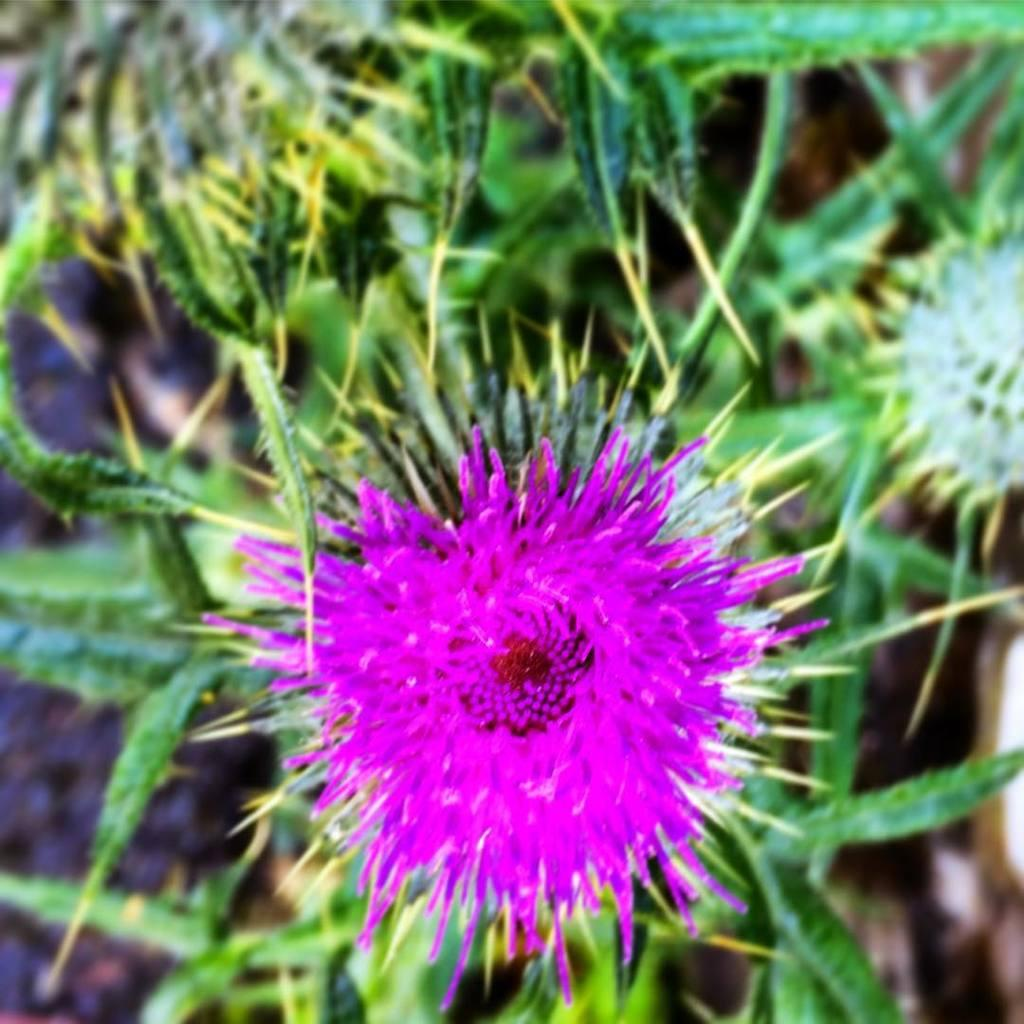What type of flower can be seen in the image? There is a purple flower in the image. How would you describe the background of the image? The background of the image is slightly blurred. What else can be seen in the background of the image? There are plants visible in the background of the image. What type of sign can be seen in the image? There is no sign present in the image; it features a purple flower and plants in the background. Is there any corn visible in the image? There is no corn present in the image. 